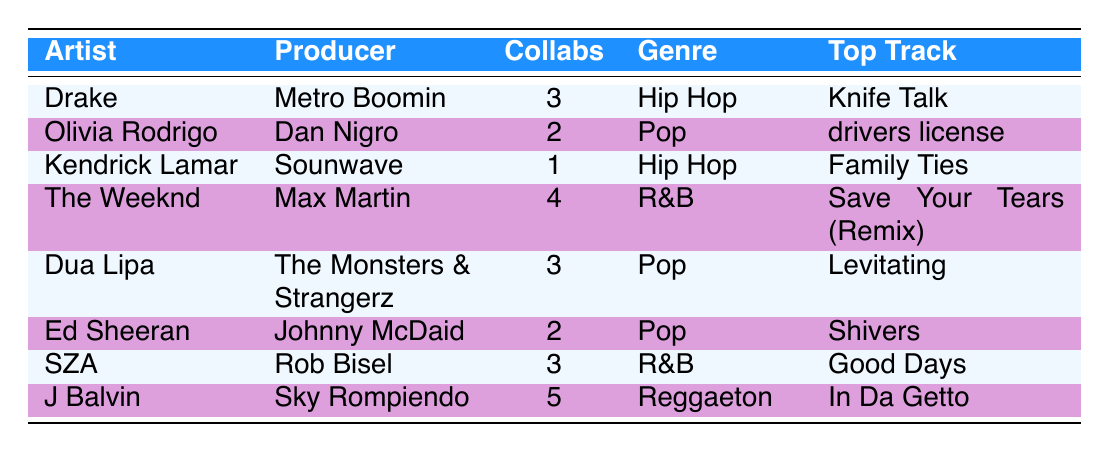What's the top track for J Balvin? According to the table, J Balvin's top track is listed as "In Da Getto."
Answer: In Da Getto How many collaborations did The Weeknd have with Max Martin last year? The table shows that The Weeknd collaborated 4 times with Max Martin last year.
Answer: 4 Which artist had the least collaborations last year? By examining the collaborations last year, Kendrick Lamar had the least with only 1 collaboration.
Answer: Kendrick Lamar What is the total number of collaborations between Drake, Dua Lipa, and SZA last year? Summing the collaborations: Drake (3) + Dua Lipa (3) + SZA (3) = 9 collaborations total.
Answer: 9 Did any artist collaborate with more than 4 producers last year? No, the table does not show any artist who collaborated with more than 4 producers last year, as the maximum collaborations observed is 5.
Answer: No What genre has the highest total number of collaborations based on the data? The total collaborations per genre are: Hip Hop (4), Pop (7), R&B (7), and Reggaeton (5). Both Pop and R&B have the highest at 7 collaborations each.
Answer: Pop and R&B Which artist had more collaborations last year, Olivia Rodrigo or Ed Sheeran? Olivia Rodrigo had 2 collaborations, while Ed Sheeran also had 2 collaborations. They had the same number of collaborations last year.
Answer: Same number (2) If we combine the collaborations of all artists, what would that total be? Adding all collaborations: 3 + 2 + 1 + 4 + 3 + 2 + 3 + 5 = 23 total collaborations across all artists.
Answer: 23 Which producer worked with the most artists in this data? By reviewing the producers, Metro Boomin worked once with Drake, while Dan Nigro worked with Olivia Rodrigo only once as well. Since we do not have data showing producers collaborating with multiple artists, we cannot determine a definitive maximum.
Answer: Cannot determine from the data 